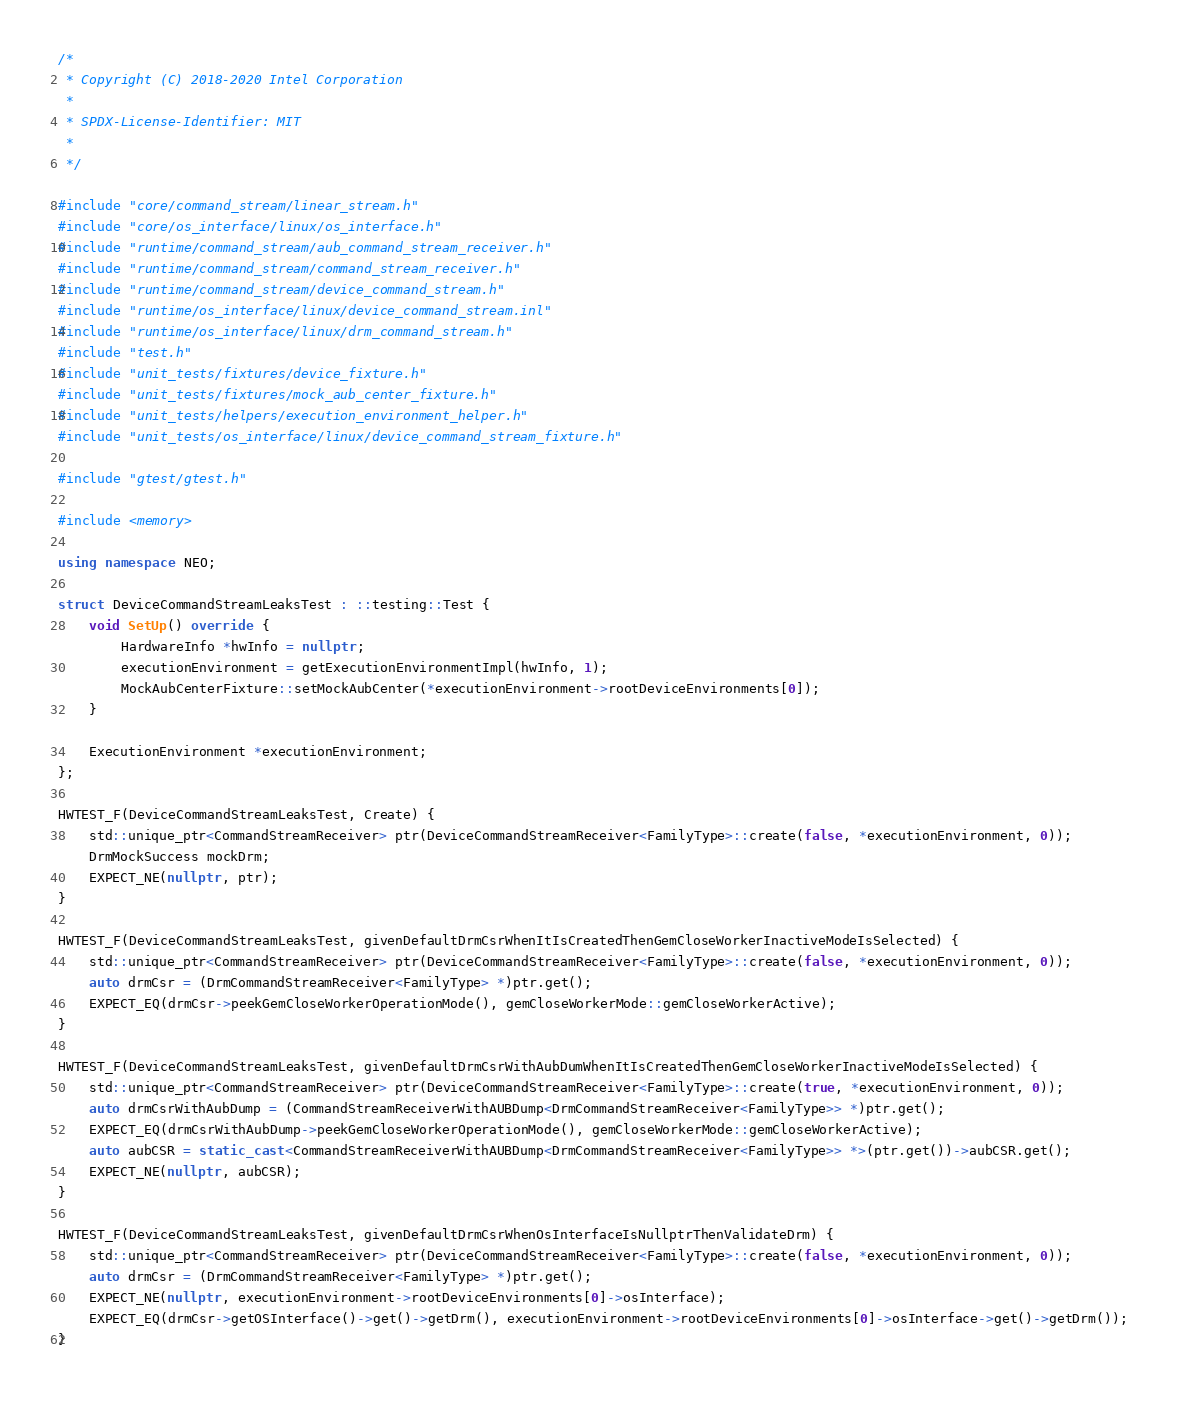<code> <loc_0><loc_0><loc_500><loc_500><_C++_>/*
 * Copyright (C) 2018-2020 Intel Corporation
 *
 * SPDX-License-Identifier: MIT
 *
 */

#include "core/command_stream/linear_stream.h"
#include "core/os_interface/linux/os_interface.h"
#include "runtime/command_stream/aub_command_stream_receiver.h"
#include "runtime/command_stream/command_stream_receiver.h"
#include "runtime/command_stream/device_command_stream.h"
#include "runtime/os_interface/linux/device_command_stream.inl"
#include "runtime/os_interface/linux/drm_command_stream.h"
#include "test.h"
#include "unit_tests/fixtures/device_fixture.h"
#include "unit_tests/fixtures/mock_aub_center_fixture.h"
#include "unit_tests/helpers/execution_environment_helper.h"
#include "unit_tests/os_interface/linux/device_command_stream_fixture.h"

#include "gtest/gtest.h"

#include <memory>

using namespace NEO;

struct DeviceCommandStreamLeaksTest : ::testing::Test {
    void SetUp() override {
        HardwareInfo *hwInfo = nullptr;
        executionEnvironment = getExecutionEnvironmentImpl(hwInfo, 1);
        MockAubCenterFixture::setMockAubCenter(*executionEnvironment->rootDeviceEnvironments[0]);
    }

    ExecutionEnvironment *executionEnvironment;
};

HWTEST_F(DeviceCommandStreamLeaksTest, Create) {
    std::unique_ptr<CommandStreamReceiver> ptr(DeviceCommandStreamReceiver<FamilyType>::create(false, *executionEnvironment, 0));
    DrmMockSuccess mockDrm;
    EXPECT_NE(nullptr, ptr);
}

HWTEST_F(DeviceCommandStreamLeaksTest, givenDefaultDrmCsrWhenItIsCreatedThenGemCloseWorkerInactiveModeIsSelected) {
    std::unique_ptr<CommandStreamReceiver> ptr(DeviceCommandStreamReceiver<FamilyType>::create(false, *executionEnvironment, 0));
    auto drmCsr = (DrmCommandStreamReceiver<FamilyType> *)ptr.get();
    EXPECT_EQ(drmCsr->peekGemCloseWorkerOperationMode(), gemCloseWorkerMode::gemCloseWorkerActive);
}

HWTEST_F(DeviceCommandStreamLeaksTest, givenDefaultDrmCsrWithAubDumWhenItIsCreatedThenGemCloseWorkerInactiveModeIsSelected) {
    std::unique_ptr<CommandStreamReceiver> ptr(DeviceCommandStreamReceiver<FamilyType>::create(true, *executionEnvironment, 0));
    auto drmCsrWithAubDump = (CommandStreamReceiverWithAUBDump<DrmCommandStreamReceiver<FamilyType>> *)ptr.get();
    EXPECT_EQ(drmCsrWithAubDump->peekGemCloseWorkerOperationMode(), gemCloseWorkerMode::gemCloseWorkerActive);
    auto aubCSR = static_cast<CommandStreamReceiverWithAUBDump<DrmCommandStreamReceiver<FamilyType>> *>(ptr.get())->aubCSR.get();
    EXPECT_NE(nullptr, aubCSR);
}

HWTEST_F(DeviceCommandStreamLeaksTest, givenDefaultDrmCsrWhenOsInterfaceIsNullptrThenValidateDrm) {
    std::unique_ptr<CommandStreamReceiver> ptr(DeviceCommandStreamReceiver<FamilyType>::create(false, *executionEnvironment, 0));
    auto drmCsr = (DrmCommandStreamReceiver<FamilyType> *)ptr.get();
    EXPECT_NE(nullptr, executionEnvironment->rootDeviceEnvironments[0]->osInterface);
    EXPECT_EQ(drmCsr->getOSInterface()->get()->getDrm(), executionEnvironment->rootDeviceEnvironments[0]->osInterface->get()->getDrm());
}
</code> 